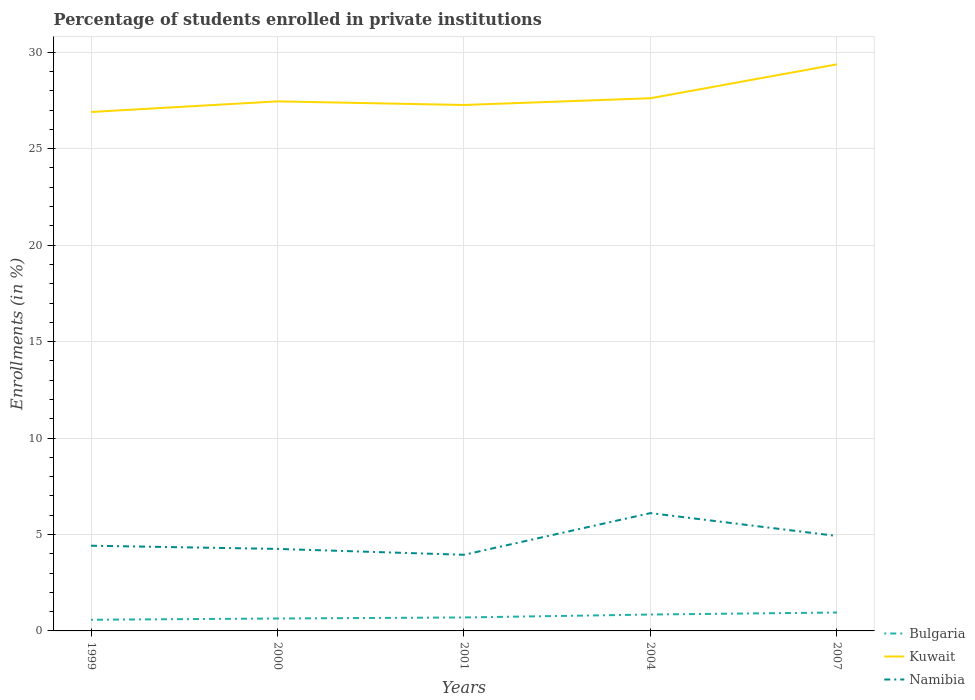How many different coloured lines are there?
Give a very brief answer. 3. Does the line corresponding to Namibia intersect with the line corresponding to Bulgaria?
Provide a succinct answer. No. Is the number of lines equal to the number of legend labels?
Offer a terse response. Yes. Across all years, what is the maximum percentage of trained teachers in Bulgaria?
Offer a very short reply. 0.58. What is the total percentage of trained teachers in Bulgaria in the graph?
Provide a short and direct response. -0.26. What is the difference between the highest and the second highest percentage of trained teachers in Namibia?
Keep it short and to the point. 2.16. Is the percentage of trained teachers in Namibia strictly greater than the percentage of trained teachers in Kuwait over the years?
Make the answer very short. Yes. How many lines are there?
Give a very brief answer. 3. What is the difference between two consecutive major ticks on the Y-axis?
Offer a terse response. 5. Are the values on the major ticks of Y-axis written in scientific E-notation?
Make the answer very short. No. Does the graph contain grids?
Offer a very short reply. Yes. What is the title of the graph?
Provide a succinct answer. Percentage of students enrolled in private institutions. Does "Equatorial Guinea" appear as one of the legend labels in the graph?
Offer a terse response. No. What is the label or title of the Y-axis?
Give a very brief answer. Enrollments (in %). What is the Enrollments (in %) in Bulgaria in 1999?
Provide a succinct answer. 0.58. What is the Enrollments (in %) of Kuwait in 1999?
Keep it short and to the point. 26.9. What is the Enrollments (in %) of Namibia in 1999?
Provide a short and direct response. 4.42. What is the Enrollments (in %) of Bulgaria in 2000?
Offer a very short reply. 0.64. What is the Enrollments (in %) of Kuwait in 2000?
Offer a very short reply. 27.45. What is the Enrollments (in %) of Namibia in 2000?
Your answer should be compact. 4.25. What is the Enrollments (in %) in Bulgaria in 2001?
Ensure brevity in your answer.  0.7. What is the Enrollments (in %) of Kuwait in 2001?
Your answer should be very brief. 27.27. What is the Enrollments (in %) in Namibia in 2001?
Provide a short and direct response. 3.95. What is the Enrollments (in %) of Bulgaria in 2004?
Provide a short and direct response. 0.85. What is the Enrollments (in %) of Kuwait in 2004?
Keep it short and to the point. 27.61. What is the Enrollments (in %) of Namibia in 2004?
Make the answer very short. 6.11. What is the Enrollments (in %) of Bulgaria in 2007?
Your answer should be very brief. 0.95. What is the Enrollments (in %) of Kuwait in 2007?
Offer a terse response. 29.37. What is the Enrollments (in %) of Namibia in 2007?
Ensure brevity in your answer.  4.92. Across all years, what is the maximum Enrollments (in %) in Bulgaria?
Provide a succinct answer. 0.95. Across all years, what is the maximum Enrollments (in %) of Kuwait?
Provide a short and direct response. 29.37. Across all years, what is the maximum Enrollments (in %) of Namibia?
Make the answer very short. 6.11. Across all years, what is the minimum Enrollments (in %) of Bulgaria?
Keep it short and to the point. 0.58. Across all years, what is the minimum Enrollments (in %) of Kuwait?
Provide a short and direct response. 26.9. Across all years, what is the minimum Enrollments (in %) of Namibia?
Give a very brief answer. 3.95. What is the total Enrollments (in %) of Bulgaria in the graph?
Your response must be concise. 3.73. What is the total Enrollments (in %) in Kuwait in the graph?
Your answer should be compact. 138.61. What is the total Enrollments (in %) of Namibia in the graph?
Your answer should be compact. 23.65. What is the difference between the Enrollments (in %) of Bulgaria in 1999 and that in 2000?
Your response must be concise. -0.06. What is the difference between the Enrollments (in %) in Kuwait in 1999 and that in 2000?
Your response must be concise. -0.55. What is the difference between the Enrollments (in %) in Namibia in 1999 and that in 2000?
Keep it short and to the point. 0.17. What is the difference between the Enrollments (in %) in Bulgaria in 1999 and that in 2001?
Offer a very short reply. -0.12. What is the difference between the Enrollments (in %) in Kuwait in 1999 and that in 2001?
Your response must be concise. -0.36. What is the difference between the Enrollments (in %) in Namibia in 1999 and that in 2001?
Ensure brevity in your answer.  0.47. What is the difference between the Enrollments (in %) in Bulgaria in 1999 and that in 2004?
Offer a terse response. -0.27. What is the difference between the Enrollments (in %) in Kuwait in 1999 and that in 2004?
Your answer should be very brief. -0.71. What is the difference between the Enrollments (in %) in Namibia in 1999 and that in 2004?
Your answer should be compact. -1.69. What is the difference between the Enrollments (in %) of Bulgaria in 1999 and that in 2007?
Your answer should be compact. -0.38. What is the difference between the Enrollments (in %) in Kuwait in 1999 and that in 2007?
Keep it short and to the point. -2.47. What is the difference between the Enrollments (in %) in Namibia in 1999 and that in 2007?
Offer a terse response. -0.5. What is the difference between the Enrollments (in %) of Bulgaria in 2000 and that in 2001?
Offer a terse response. -0.05. What is the difference between the Enrollments (in %) of Kuwait in 2000 and that in 2001?
Keep it short and to the point. 0.19. What is the difference between the Enrollments (in %) in Namibia in 2000 and that in 2001?
Offer a very short reply. 0.3. What is the difference between the Enrollments (in %) of Bulgaria in 2000 and that in 2004?
Make the answer very short. -0.21. What is the difference between the Enrollments (in %) of Kuwait in 2000 and that in 2004?
Ensure brevity in your answer.  -0.16. What is the difference between the Enrollments (in %) of Namibia in 2000 and that in 2004?
Your response must be concise. -1.86. What is the difference between the Enrollments (in %) of Bulgaria in 2000 and that in 2007?
Your answer should be compact. -0.31. What is the difference between the Enrollments (in %) in Kuwait in 2000 and that in 2007?
Your answer should be compact. -1.92. What is the difference between the Enrollments (in %) in Namibia in 2000 and that in 2007?
Provide a short and direct response. -0.67. What is the difference between the Enrollments (in %) in Bulgaria in 2001 and that in 2004?
Your response must be concise. -0.15. What is the difference between the Enrollments (in %) in Kuwait in 2001 and that in 2004?
Your answer should be compact. -0.35. What is the difference between the Enrollments (in %) in Namibia in 2001 and that in 2004?
Ensure brevity in your answer.  -2.16. What is the difference between the Enrollments (in %) in Bulgaria in 2001 and that in 2007?
Your response must be concise. -0.26. What is the difference between the Enrollments (in %) of Kuwait in 2001 and that in 2007?
Provide a succinct answer. -2.11. What is the difference between the Enrollments (in %) of Namibia in 2001 and that in 2007?
Your answer should be very brief. -0.97. What is the difference between the Enrollments (in %) in Bulgaria in 2004 and that in 2007?
Offer a very short reply. -0.1. What is the difference between the Enrollments (in %) in Kuwait in 2004 and that in 2007?
Give a very brief answer. -1.76. What is the difference between the Enrollments (in %) of Namibia in 2004 and that in 2007?
Provide a succinct answer. 1.19. What is the difference between the Enrollments (in %) of Bulgaria in 1999 and the Enrollments (in %) of Kuwait in 2000?
Your response must be concise. -26.87. What is the difference between the Enrollments (in %) in Bulgaria in 1999 and the Enrollments (in %) in Namibia in 2000?
Provide a short and direct response. -3.67. What is the difference between the Enrollments (in %) in Kuwait in 1999 and the Enrollments (in %) in Namibia in 2000?
Your answer should be very brief. 22.65. What is the difference between the Enrollments (in %) in Bulgaria in 1999 and the Enrollments (in %) in Kuwait in 2001?
Provide a succinct answer. -26.69. What is the difference between the Enrollments (in %) in Bulgaria in 1999 and the Enrollments (in %) in Namibia in 2001?
Ensure brevity in your answer.  -3.37. What is the difference between the Enrollments (in %) in Kuwait in 1999 and the Enrollments (in %) in Namibia in 2001?
Provide a succinct answer. 22.96. What is the difference between the Enrollments (in %) of Bulgaria in 1999 and the Enrollments (in %) of Kuwait in 2004?
Offer a terse response. -27.04. What is the difference between the Enrollments (in %) in Bulgaria in 1999 and the Enrollments (in %) in Namibia in 2004?
Provide a succinct answer. -5.53. What is the difference between the Enrollments (in %) in Kuwait in 1999 and the Enrollments (in %) in Namibia in 2004?
Your response must be concise. 20.8. What is the difference between the Enrollments (in %) of Bulgaria in 1999 and the Enrollments (in %) of Kuwait in 2007?
Give a very brief answer. -28.79. What is the difference between the Enrollments (in %) in Bulgaria in 1999 and the Enrollments (in %) in Namibia in 2007?
Offer a terse response. -4.34. What is the difference between the Enrollments (in %) of Kuwait in 1999 and the Enrollments (in %) of Namibia in 2007?
Your response must be concise. 21.98. What is the difference between the Enrollments (in %) of Bulgaria in 2000 and the Enrollments (in %) of Kuwait in 2001?
Offer a terse response. -26.62. What is the difference between the Enrollments (in %) in Bulgaria in 2000 and the Enrollments (in %) in Namibia in 2001?
Offer a terse response. -3.3. What is the difference between the Enrollments (in %) in Kuwait in 2000 and the Enrollments (in %) in Namibia in 2001?
Offer a very short reply. 23.51. What is the difference between the Enrollments (in %) of Bulgaria in 2000 and the Enrollments (in %) of Kuwait in 2004?
Provide a short and direct response. -26.97. What is the difference between the Enrollments (in %) of Bulgaria in 2000 and the Enrollments (in %) of Namibia in 2004?
Keep it short and to the point. -5.46. What is the difference between the Enrollments (in %) of Kuwait in 2000 and the Enrollments (in %) of Namibia in 2004?
Your answer should be very brief. 21.35. What is the difference between the Enrollments (in %) of Bulgaria in 2000 and the Enrollments (in %) of Kuwait in 2007?
Give a very brief answer. -28.73. What is the difference between the Enrollments (in %) of Bulgaria in 2000 and the Enrollments (in %) of Namibia in 2007?
Provide a succinct answer. -4.28. What is the difference between the Enrollments (in %) in Kuwait in 2000 and the Enrollments (in %) in Namibia in 2007?
Ensure brevity in your answer.  22.53. What is the difference between the Enrollments (in %) of Bulgaria in 2001 and the Enrollments (in %) of Kuwait in 2004?
Give a very brief answer. -26.92. What is the difference between the Enrollments (in %) of Bulgaria in 2001 and the Enrollments (in %) of Namibia in 2004?
Give a very brief answer. -5.41. What is the difference between the Enrollments (in %) in Kuwait in 2001 and the Enrollments (in %) in Namibia in 2004?
Your response must be concise. 21.16. What is the difference between the Enrollments (in %) in Bulgaria in 2001 and the Enrollments (in %) in Kuwait in 2007?
Your answer should be very brief. -28.67. What is the difference between the Enrollments (in %) in Bulgaria in 2001 and the Enrollments (in %) in Namibia in 2007?
Make the answer very short. -4.22. What is the difference between the Enrollments (in %) in Kuwait in 2001 and the Enrollments (in %) in Namibia in 2007?
Offer a very short reply. 22.34. What is the difference between the Enrollments (in %) of Bulgaria in 2004 and the Enrollments (in %) of Kuwait in 2007?
Your response must be concise. -28.52. What is the difference between the Enrollments (in %) in Bulgaria in 2004 and the Enrollments (in %) in Namibia in 2007?
Offer a terse response. -4.07. What is the difference between the Enrollments (in %) in Kuwait in 2004 and the Enrollments (in %) in Namibia in 2007?
Keep it short and to the point. 22.69. What is the average Enrollments (in %) of Bulgaria per year?
Make the answer very short. 0.75. What is the average Enrollments (in %) of Kuwait per year?
Your response must be concise. 27.72. What is the average Enrollments (in %) in Namibia per year?
Make the answer very short. 4.73. In the year 1999, what is the difference between the Enrollments (in %) of Bulgaria and Enrollments (in %) of Kuwait?
Your response must be concise. -26.32. In the year 1999, what is the difference between the Enrollments (in %) of Bulgaria and Enrollments (in %) of Namibia?
Your answer should be very brief. -3.84. In the year 1999, what is the difference between the Enrollments (in %) of Kuwait and Enrollments (in %) of Namibia?
Your answer should be compact. 22.49. In the year 2000, what is the difference between the Enrollments (in %) in Bulgaria and Enrollments (in %) in Kuwait?
Offer a terse response. -26.81. In the year 2000, what is the difference between the Enrollments (in %) in Bulgaria and Enrollments (in %) in Namibia?
Your answer should be compact. -3.61. In the year 2000, what is the difference between the Enrollments (in %) of Kuwait and Enrollments (in %) of Namibia?
Give a very brief answer. 23.2. In the year 2001, what is the difference between the Enrollments (in %) of Bulgaria and Enrollments (in %) of Kuwait?
Your answer should be compact. -26.57. In the year 2001, what is the difference between the Enrollments (in %) in Bulgaria and Enrollments (in %) in Namibia?
Provide a succinct answer. -3.25. In the year 2001, what is the difference between the Enrollments (in %) in Kuwait and Enrollments (in %) in Namibia?
Ensure brevity in your answer.  23.32. In the year 2004, what is the difference between the Enrollments (in %) in Bulgaria and Enrollments (in %) in Kuwait?
Make the answer very short. -26.77. In the year 2004, what is the difference between the Enrollments (in %) in Bulgaria and Enrollments (in %) in Namibia?
Offer a terse response. -5.26. In the year 2004, what is the difference between the Enrollments (in %) in Kuwait and Enrollments (in %) in Namibia?
Offer a terse response. 21.51. In the year 2007, what is the difference between the Enrollments (in %) in Bulgaria and Enrollments (in %) in Kuwait?
Your answer should be compact. -28.42. In the year 2007, what is the difference between the Enrollments (in %) in Bulgaria and Enrollments (in %) in Namibia?
Provide a short and direct response. -3.97. In the year 2007, what is the difference between the Enrollments (in %) in Kuwait and Enrollments (in %) in Namibia?
Keep it short and to the point. 24.45. What is the ratio of the Enrollments (in %) of Bulgaria in 1999 to that in 2000?
Provide a succinct answer. 0.9. What is the ratio of the Enrollments (in %) in Kuwait in 1999 to that in 2000?
Make the answer very short. 0.98. What is the ratio of the Enrollments (in %) in Namibia in 1999 to that in 2000?
Ensure brevity in your answer.  1.04. What is the ratio of the Enrollments (in %) of Bulgaria in 1999 to that in 2001?
Make the answer very short. 0.83. What is the ratio of the Enrollments (in %) in Kuwait in 1999 to that in 2001?
Your answer should be very brief. 0.99. What is the ratio of the Enrollments (in %) in Namibia in 1999 to that in 2001?
Your response must be concise. 1.12. What is the ratio of the Enrollments (in %) in Bulgaria in 1999 to that in 2004?
Your answer should be compact. 0.68. What is the ratio of the Enrollments (in %) in Kuwait in 1999 to that in 2004?
Your response must be concise. 0.97. What is the ratio of the Enrollments (in %) of Namibia in 1999 to that in 2004?
Offer a terse response. 0.72. What is the ratio of the Enrollments (in %) in Bulgaria in 1999 to that in 2007?
Offer a terse response. 0.61. What is the ratio of the Enrollments (in %) of Kuwait in 1999 to that in 2007?
Your response must be concise. 0.92. What is the ratio of the Enrollments (in %) in Namibia in 1999 to that in 2007?
Your answer should be very brief. 0.9. What is the ratio of the Enrollments (in %) in Bulgaria in 2000 to that in 2001?
Your answer should be very brief. 0.92. What is the ratio of the Enrollments (in %) of Namibia in 2000 to that in 2001?
Make the answer very short. 1.08. What is the ratio of the Enrollments (in %) of Bulgaria in 2000 to that in 2004?
Provide a short and direct response. 0.76. What is the ratio of the Enrollments (in %) of Namibia in 2000 to that in 2004?
Your response must be concise. 0.7. What is the ratio of the Enrollments (in %) of Bulgaria in 2000 to that in 2007?
Your answer should be very brief. 0.67. What is the ratio of the Enrollments (in %) in Kuwait in 2000 to that in 2007?
Give a very brief answer. 0.93. What is the ratio of the Enrollments (in %) of Namibia in 2000 to that in 2007?
Ensure brevity in your answer.  0.86. What is the ratio of the Enrollments (in %) in Bulgaria in 2001 to that in 2004?
Keep it short and to the point. 0.82. What is the ratio of the Enrollments (in %) of Kuwait in 2001 to that in 2004?
Give a very brief answer. 0.99. What is the ratio of the Enrollments (in %) of Namibia in 2001 to that in 2004?
Offer a very short reply. 0.65. What is the ratio of the Enrollments (in %) of Bulgaria in 2001 to that in 2007?
Ensure brevity in your answer.  0.73. What is the ratio of the Enrollments (in %) of Kuwait in 2001 to that in 2007?
Your response must be concise. 0.93. What is the ratio of the Enrollments (in %) of Namibia in 2001 to that in 2007?
Provide a short and direct response. 0.8. What is the ratio of the Enrollments (in %) in Bulgaria in 2004 to that in 2007?
Keep it short and to the point. 0.89. What is the ratio of the Enrollments (in %) in Kuwait in 2004 to that in 2007?
Your answer should be very brief. 0.94. What is the ratio of the Enrollments (in %) of Namibia in 2004 to that in 2007?
Your answer should be compact. 1.24. What is the difference between the highest and the second highest Enrollments (in %) of Bulgaria?
Your response must be concise. 0.1. What is the difference between the highest and the second highest Enrollments (in %) of Kuwait?
Your answer should be compact. 1.76. What is the difference between the highest and the second highest Enrollments (in %) of Namibia?
Ensure brevity in your answer.  1.19. What is the difference between the highest and the lowest Enrollments (in %) in Bulgaria?
Make the answer very short. 0.38. What is the difference between the highest and the lowest Enrollments (in %) in Kuwait?
Offer a terse response. 2.47. What is the difference between the highest and the lowest Enrollments (in %) of Namibia?
Offer a terse response. 2.16. 